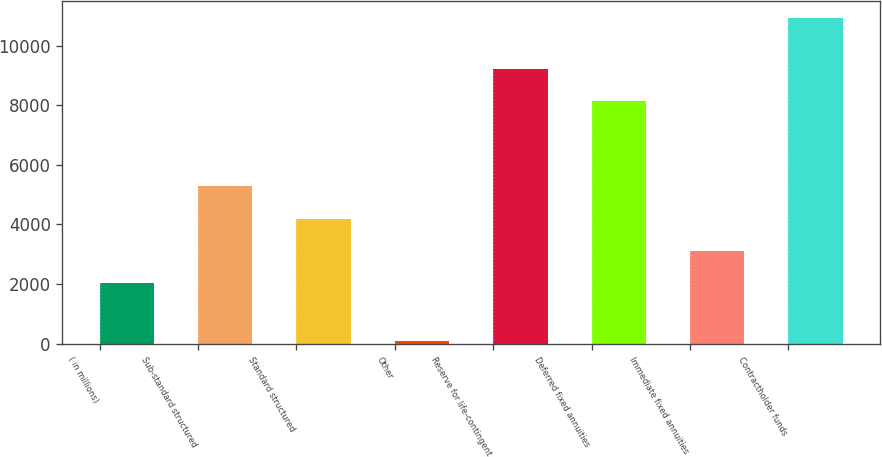<chart> <loc_0><loc_0><loc_500><loc_500><bar_chart><fcel>( in millions)<fcel>Sub-standard structured<fcel>Standard structured<fcel>Other<fcel>Reserve for life-contingent<fcel>Deferred fixed annuities<fcel>Immediate fixed annuities<fcel>Contractholder funds<nl><fcel>2017<fcel>5284<fcel>4187.2<fcel>85<fcel>9213.1<fcel>8128<fcel>3102.1<fcel>10936<nl></chart> 